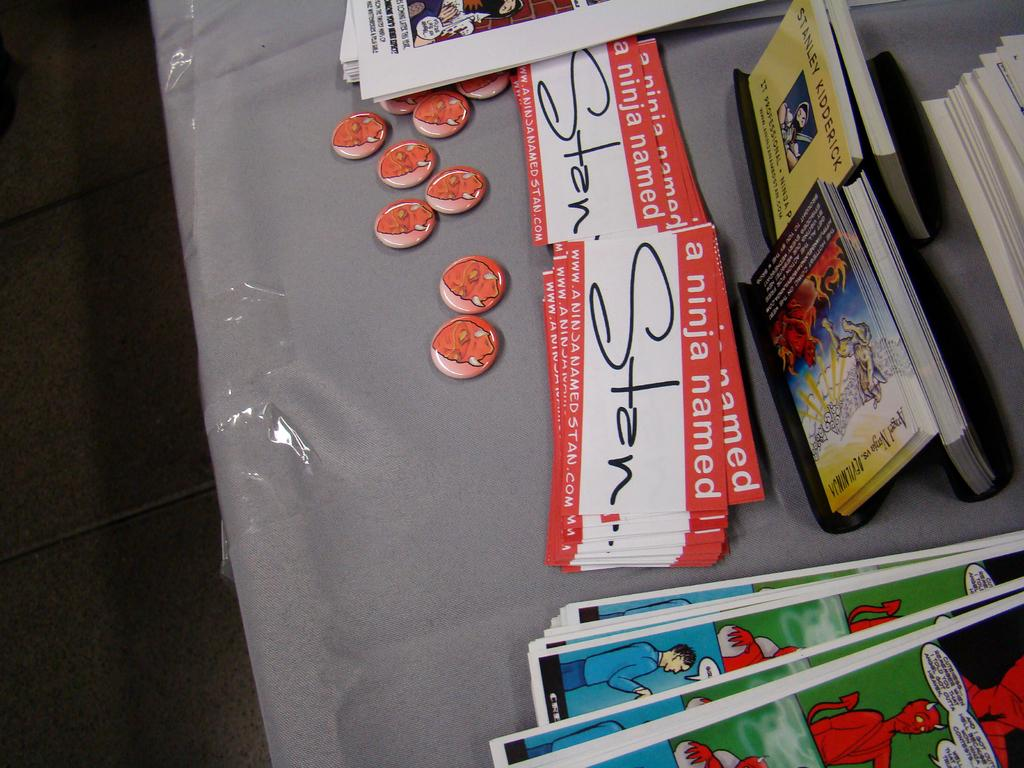<image>
Share a concise interpretation of the image provided. The name tag says A NInja Named Stan 